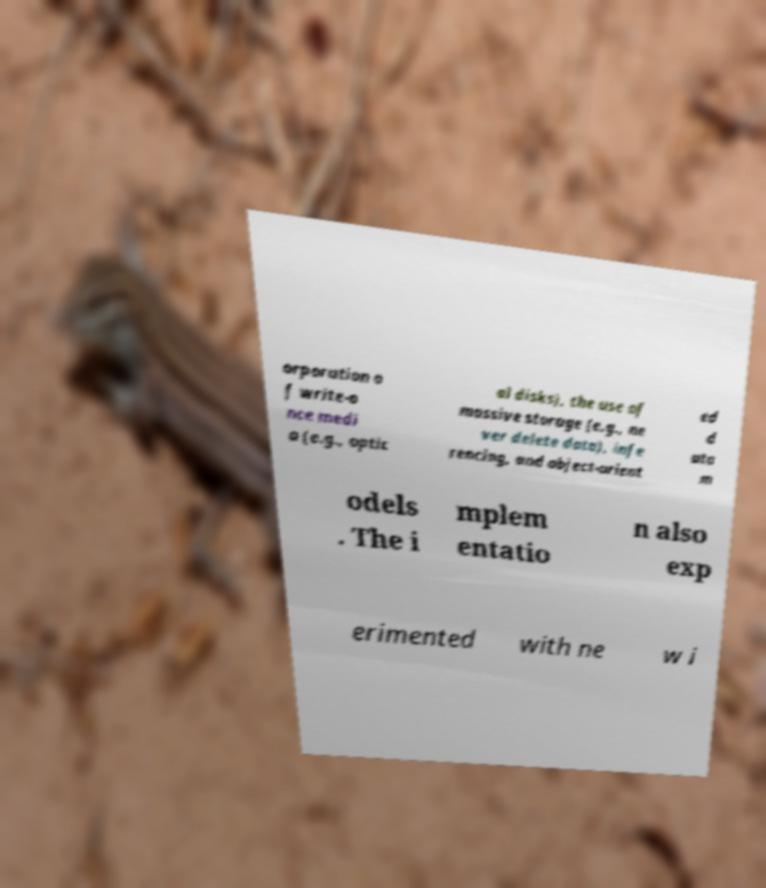I need the written content from this picture converted into text. Can you do that? orporation o f write-o nce medi a (e.g., optic al disks), the use of massive storage (e.g., ne ver delete data), infe rencing, and object-orient ed d ata m odels . The i mplem entatio n also exp erimented with ne w i 